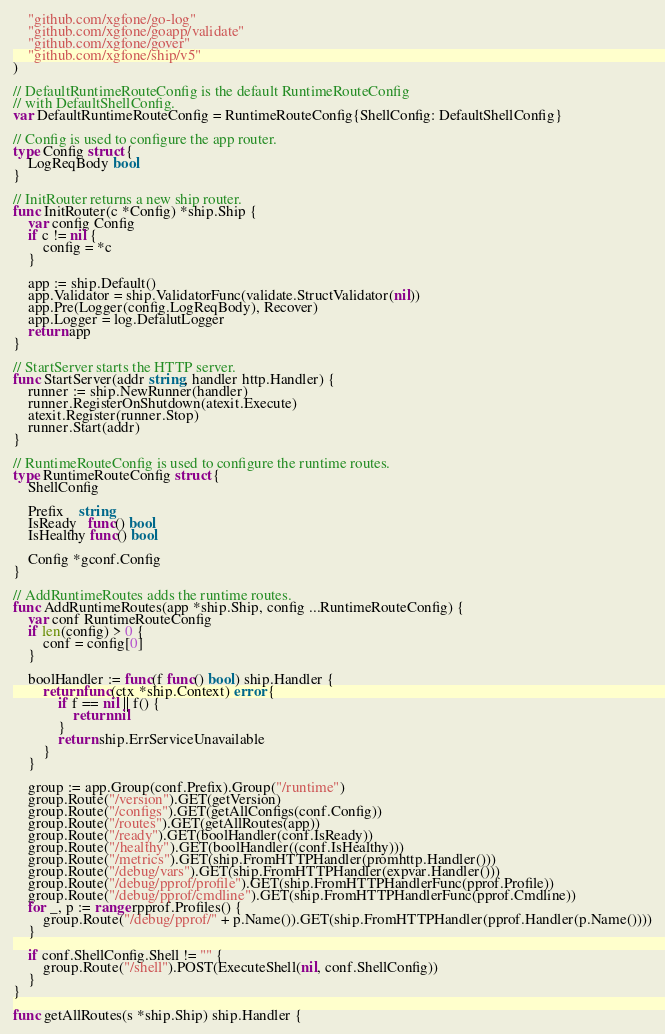Convert code to text. <code><loc_0><loc_0><loc_500><loc_500><_Go_>	"github.com/xgfone/go-log"
	"github.com/xgfone/goapp/validate"
	"github.com/xgfone/gover"
	"github.com/xgfone/ship/v5"
)

// DefaultRuntimeRouteConfig is the default RuntimeRouteConfig
// with DefaultShellConfig.
var DefaultRuntimeRouteConfig = RuntimeRouteConfig{ShellConfig: DefaultShellConfig}

// Config is used to configure the app router.
type Config struct {
	LogReqBody bool
}

// InitRouter returns a new ship router.
func InitRouter(c *Config) *ship.Ship {
	var config Config
	if c != nil {
		config = *c
	}

	app := ship.Default()
	app.Validator = ship.ValidatorFunc(validate.StructValidator(nil))
	app.Pre(Logger(config.LogReqBody), Recover)
	app.Logger = log.DefalutLogger
	return app
}

// StartServer starts the HTTP server.
func StartServer(addr string, handler http.Handler) {
	runner := ship.NewRunner(handler)
	runner.RegisterOnShutdown(atexit.Execute)
	atexit.Register(runner.Stop)
	runner.Start(addr)
}

// RuntimeRouteConfig is used to configure the runtime routes.
type RuntimeRouteConfig struct {
	ShellConfig

	Prefix    string
	IsReady   func() bool
	IsHealthy func() bool

	Config *gconf.Config
}

// AddRuntimeRoutes adds the runtime routes.
func AddRuntimeRoutes(app *ship.Ship, config ...RuntimeRouteConfig) {
	var conf RuntimeRouteConfig
	if len(config) > 0 {
		conf = config[0]
	}

	boolHandler := func(f func() bool) ship.Handler {
		return func(ctx *ship.Context) error {
			if f == nil || f() {
				return nil
			}
			return ship.ErrServiceUnavailable
		}
	}

	group := app.Group(conf.Prefix).Group("/runtime")
	group.Route("/version").GET(getVersion)
	group.Route("/configs").GET(getAllConfigs(conf.Config))
	group.Route("/routes").GET(getAllRoutes(app))
	group.Route("/ready").GET(boolHandler(conf.IsReady))
	group.Route("/healthy").GET(boolHandler((conf.IsHealthy)))
	group.Route("/metrics").GET(ship.FromHTTPHandler(promhttp.Handler()))
	group.Route("/debug/vars").GET(ship.FromHTTPHandler(expvar.Handler()))
	group.Route("/debug/pprof/profile").GET(ship.FromHTTPHandlerFunc(pprof.Profile))
	group.Route("/debug/pprof/cmdline").GET(ship.FromHTTPHandlerFunc(pprof.Cmdline))
	for _, p := range rpprof.Profiles() {
		group.Route("/debug/pprof/" + p.Name()).GET(ship.FromHTTPHandler(pprof.Handler(p.Name())))
	}

	if conf.ShellConfig.Shell != "" {
		group.Route("/shell").POST(ExecuteShell(nil, conf.ShellConfig))
	}
}

func getAllRoutes(s *ship.Ship) ship.Handler {</code> 